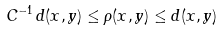<formula> <loc_0><loc_0><loc_500><loc_500>C ^ { - 1 } \, d ( x , y ) \leq \rho ( x , y ) \leq d ( x , y )</formula> 